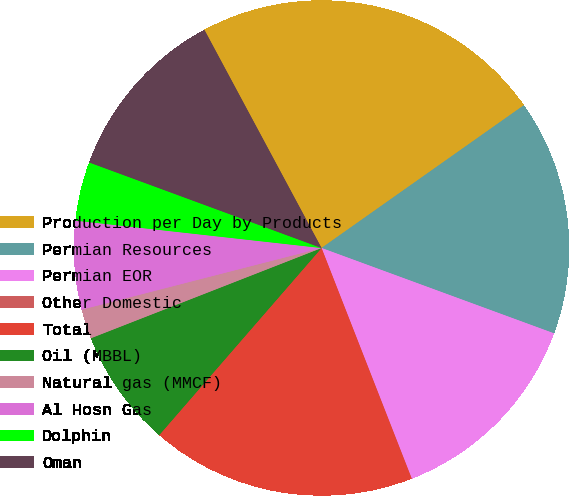<chart> <loc_0><loc_0><loc_500><loc_500><pie_chart><fcel>Production per Day by Products<fcel>Permian Resources<fcel>Permian EOR<fcel>Other Domestic<fcel>Total<fcel>Oil (MBBL)<fcel>Natural gas (MMCF)<fcel>Al Hosn Gas<fcel>Dolphin<fcel>Oman<nl><fcel>23.06%<fcel>15.38%<fcel>13.46%<fcel>0.01%<fcel>17.3%<fcel>7.69%<fcel>1.93%<fcel>5.77%<fcel>3.85%<fcel>11.54%<nl></chart> 